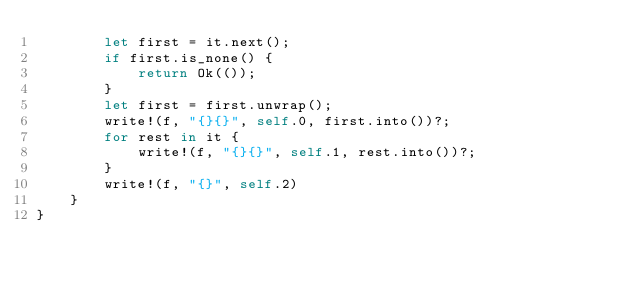<code> <loc_0><loc_0><loc_500><loc_500><_Rust_>        let first = it.next();
        if first.is_none() {
            return Ok(());
        }
        let first = first.unwrap();
        write!(f, "{}{}", self.0, first.into())?;
        for rest in it {
            write!(f, "{}{}", self.1, rest.into())?;
        }
        write!(f, "{}", self.2)
    }
}
</code> 